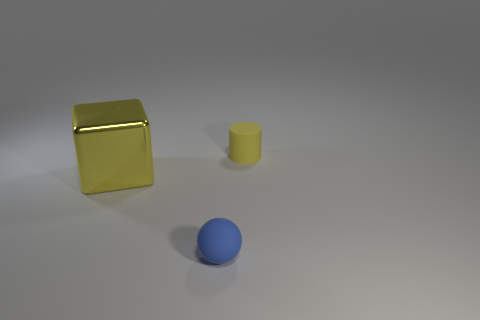What do these shapes remind you of in terms of their arrangement? The arrangement of the shapes might remind one of a minimalist art piece, where each object's placement is intentional yet invites the viewer to interpret their relationship or purpose. Could this image be used for any educational purposes? Certainly, this image could be utilized as a visual aid in educational settings to teach concepts like geometry, 3D modeling, or even color theory, as it provides clear examples of shapes and colors. 